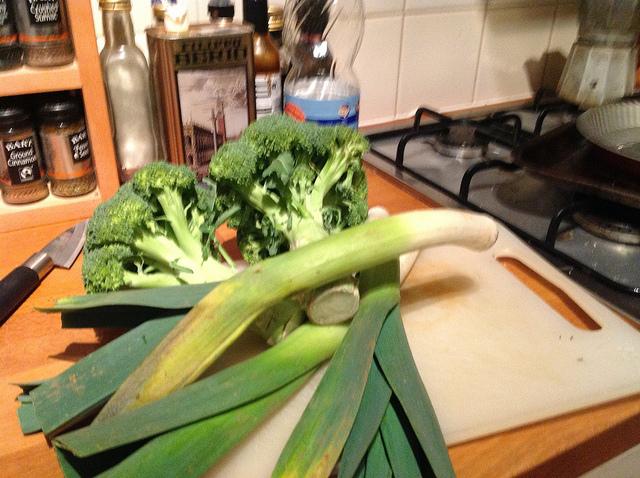Will the chef cook these together?
Write a very short answer. Yes. Is there a cutting tool in the photo?
Concise answer only. Yes. What are the vegetables on?
Be succinct. Cutting board. Does the salad contain dressing?
Answer briefly. No. What is that green item in the jar?
Quick response, please. Broccoli. 